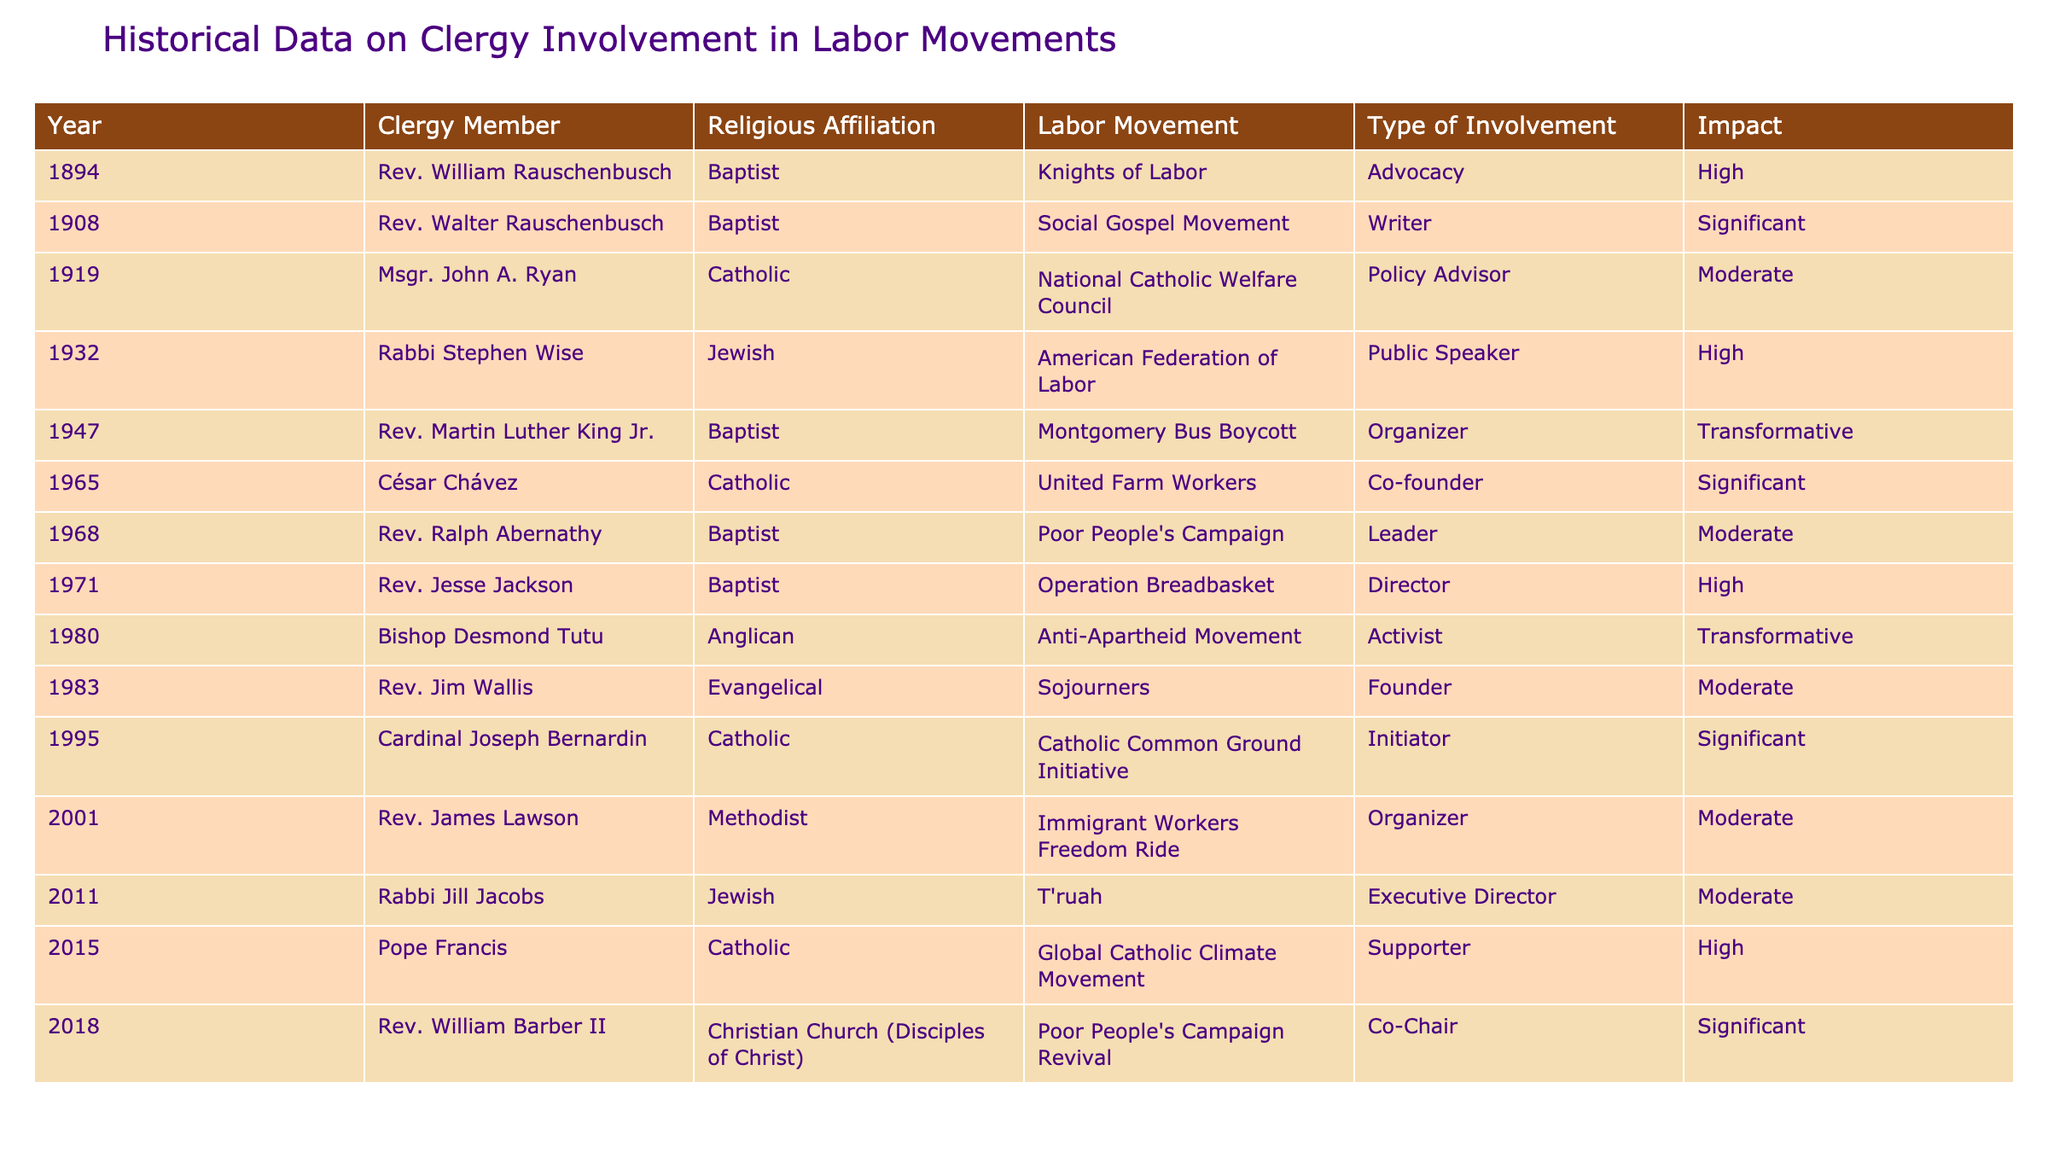What year did Rev. Martin Luther King Jr. participate in the labor movement? The table lists Rev. Martin Luther King Jr. and shows his involvement in the Montgomery Bus Boycott in the year 1947.
Answer: 1947 Which religious affiliation had the most representatives in the labor movements? By examining the table, the Baptist denomination appears multiple times, with four representatives: Rev. William Rauschenbusch, Rev. Martin Luther King Jr., Rev. Ralph Abernathy, and Rev. Jesse Jackson.
Answer: Baptist Who had a transformative impact on the labor movements according to the table? Looking at the "Impact" column, both Rev. Martin Luther King Jr. and Bishop Desmond Tutu are listed with a transformative impact.
Answer: Rev. Martin Luther King Jr. and Bishop Desmond Tutu Is there any involvement from members of the Anglican Church in labor movements? The table shows that Bishop Desmond Tutu, who is affiliated with the Anglican Church, was involved in the Anti-Apartheid Movement as an activist.
Answer: Yes What is the total number of clergy members listed in the table? By counting each row, the table lists 15 different clergy members involved in labor movements.
Answer: 15 Which labor movement had the highest impact rating and who was involved? The highest impact rating in the table is "Transformative," associated with Rev. Martin Luther King Jr. in the Montgomery Bus Boycott and Bishop Desmond Tutu in the Anti-Apartheid Movement.
Answer: Rev. Martin Luther King Jr. and Bishop Desmond Tutu In what year did the clergy member with the least impactful involvement participate in a labor movement? By scanning the "Impact" column, the least impactful involvement is marked as "Moderate," with Rev. Jim Wallis in 1983, Rev. Jesse Jackson in 1971, and others listed. The most recent one listed with moderate impact is in 2011.
Answer: 2011 Which two labor movements had clergy members with a "Significant" impact, and what were their religious affiliations? The table shows "Significant" impact for the Social Gospel Movement, led by Rev. Walter Rauschenbusch (Baptist), and the United Farm Workers, co-founded by César Chávez (Catholic).
Answer: Social Gospel Movement (Baptist), United Farm Workers (Catholic) Are there any clergy members from the Jewish faith involved in labor movements? The table lists two Jewish clergy: Rabbi Stephen Wise, involved in the American Federation of Labor, and Rabbi Jill Jacobs, who was Executive Director of T'ruah.
Answer: Yes If we categorize the clergy involvement types, which type appears most frequently? By checking the "Type of Involvement" column, it can be observed that the role of "Organizer" appears three times with Rev. Martin Luther King Jr., Rev. James Lawson, and Rev. William Barber II filling that role.
Answer: Organizer 